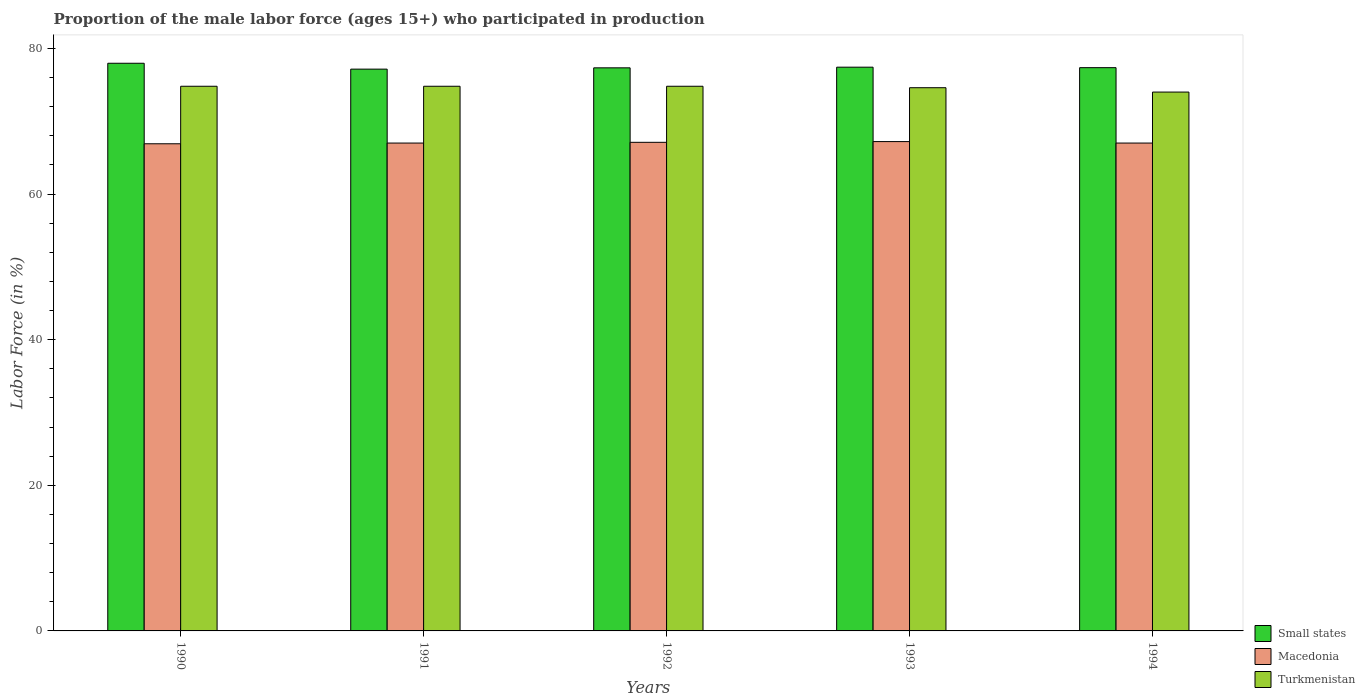How many groups of bars are there?
Give a very brief answer. 5. Are the number of bars on each tick of the X-axis equal?
Ensure brevity in your answer.  Yes. How many bars are there on the 1st tick from the left?
Your answer should be compact. 3. How many bars are there on the 2nd tick from the right?
Your response must be concise. 3. What is the label of the 4th group of bars from the left?
Provide a short and direct response. 1993. What is the proportion of the male labor force who participated in production in Turkmenistan in 1991?
Your answer should be very brief. 74.8. Across all years, what is the maximum proportion of the male labor force who participated in production in Small states?
Offer a terse response. 77.96. Across all years, what is the minimum proportion of the male labor force who participated in production in Macedonia?
Your answer should be very brief. 66.9. In which year was the proportion of the male labor force who participated in production in Small states maximum?
Give a very brief answer. 1990. In which year was the proportion of the male labor force who participated in production in Turkmenistan minimum?
Your response must be concise. 1994. What is the total proportion of the male labor force who participated in production in Turkmenistan in the graph?
Provide a short and direct response. 373. What is the difference between the proportion of the male labor force who participated in production in Turkmenistan in 1991 and that in 1993?
Ensure brevity in your answer.  0.2. What is the difference between the proportion of the male labor force who participated in production in Macedonia in 1992 and the proportion of the male labor force who participated in production in Turkmenistan in 1990?
Keep it short and to the point. -7.7. What is the average proportion of the male labor force who participated in production in Macedonia per year?
Provide a short and direct response. 67.04. In the year 1990, what is the difference between the proportion of the male labor force who participated in production in Macedonia and proportion of the male labor force who participated in production in Small states?
Keep it short and to the point. -11.06. What is the ratio of the proportion of the male labor force who participated in production in Macedonia in 1990 to that in 1991?
Give a very brief answer. 1. Is the proportion of the male labor force who participated in production in Macedonia in 1992 less than that in 1993?
Offer a very short reply. Yes. What is the difference between the highest and the second highest proportion of the male labor force who participated in production in Small states?
Make the answer very short. 0.54. What is the difference between the highest and the lowest proportion of the male labor force who participated in production in Small states?
Keep it short and to the point. 0.81. Is the sum of the proportion of the male labor force who participated in production in Small states in 1992 and 1994 greater than the maximum proportion of the male labor force who participated in production in Turkmenistan across all years?
Make the answer very short. Yes. What does the 3rd bar from the left in 1992 represents?
Ensure brevity in your answer.  Turkmenistan. What does the 3rd bar from the right in 1993 represents?
Provide a succinct answer. Small states. Is it the case that in every year, the sum of the proportion of the male labor force who participated in production in Small states and proportion of the male labor force who participated in production in Turkmenistan is greater than the proportion of the male labor force who participated in production in Macedonia?
Ensure brevity in your answer.  Yes. How many bars are there?
Keep it short and to the point. 15. Are all the bars in the graph horizontal?
Offer a terse response. No. Are the values on the major ticks of Y-axis written in scientific E-notation?
Your response must be concise. No. Does the graph contain grids?
Provide a succinct answer. No. Where does the legend appear in the graph?
Your response must be concise. Bottom right. How many legend labels are there?
Provide a succinct answer. 3. How are the legend labels stacked?
Your answer should be compact. Vertical. What is the title of the graph?
Provide a short and direct response. Proportion of the male labor force (ages 15+) who participated in production. Does "Timor-Leste" appear as one of the legend labels in the graph?
Provide a short and direct response. No. What is the Labor Force (in %) in Small states in 1990?
Your answer should be very brief. 77.96. What is the Labor Force (in %) of Macedonia in 1990?
Offer a terse response. 66.9. What is the Labor Force (in %) in Turkmenistan in 1990?
Give a very brief answer. 74.8. What is the Labor Force (in %) of Small states in 1991?
Your answer should be compact. 77.15. What is the Labor Force (in %) in Macedonia in 1991?
Give a very brief answer. 67. What is the Labor Force (in %) in Turkmenistan in 1991?
Provide a succinct answer. 74.8. What is the Labor Force (in %) in Small states in 1992?
Your answer should be very brief. 77.33. What is the Labor Force (in %) of Macedonia in 1992?
Offer a terse response. 67.1. What is the Labor Force (in %) in Turkmenistan in 1992?
Your answer should be compact. 74.8. What is the Labor Force (in %) of Small states in 1993?
Keep it short and to the point. 77.42. What is the Labor Force (in %) in Macedonia in 1993?
Your answer should be compact. 67.2. What is the Labor Force (in %) of Turkmenistan in 1993?
Your response must be concise. 74.6. What is the Labor Force (in %) of Small states in 1994?
Your answer should be compact. 77.35. What is the Labor Force (in %) of Macedonia in 1994?
Provide a succinct answer. 67. What is the Labor Force (in %) in Turkmenistan in 1994?
Your response must be concise. 74. Across all years, what is the maximum Labor Force (in %) in Small states?
Give a very brief answer. 77.96. Across all years, what is the maximum Labor Force (in %) of Macedonia?
Make the answer very short. 67.2. Across all years, what is the maximum Labor Force (in %) in Turkmenistan?
Your response must be concise. 74.8. Across all years, what is the minimum Labor Force (in %) in Small states?
Your response must be concise. 77.15. Across all years, what is the minimum Labor Force (in %) in Macedonia?
Provide a succinct answer. 66.9. What is the total Labor Force (in %) in Small states in the graph?
Your answer should be compact. 387.21. What is the total Labor Force (in %) in Macedonia in the graph?
Give a very brief answer. 335.2. What is the total Labor Force (in %) in Turkmenistan in the graph?
Provide a short and direct response. 373. What is the difference between the Labor Force (in %) of Small states in 1990 and that in 1991?
Provide a succinct answer. 0.81. What is the difference between the Labor Force (in %) of Small states in 1990 and that in 1992?
Offer a terse response. 0.63. What is the difference between the Labor Force (in %) in Macedonia in 1990 and that in 1992?
Keep it short and to the point. -0.2. What is the difference between the Labor Force (in %) in Small states in 1990 and that in 1993?
Keep it short and to the point. 0.54. What is the difference between the Labor Force (in %) in Macedonia in 1990 and that in 1993?
Your answer should be very brief. -0.3. What is the difference between the Labor Force (in %) in Turkmenistan in 1990 and that in 1993?
Provide a succinct answer. 0.2. What is the difference between the Labor Force (in %) of Small states in 1990 and that in 1994?
Your answer should be very brief. 0.61. What is the difference between the Labor Force (in %) in Turkmenistan in 1990 and that in 1994?
Keep it short and to the point. 0.8. What is the difference between the Labor Force (in %) of Small states in 1991 and that in 1992?
Your answer should be compact. -0.18. What is the difference between the Labor Force (in %) of Macedonia in 1991 and that in 1992?
Give a very brief answer. -0.1. What is the difference between the Labor Force (in %) in Small states in 1991 and that in 1993?
Keep it short and to the point. -0.27. What is the difference between the Labor Force (in %) in Macedonia in 1991 and that in 1993?
Keep it short and to the point. -0.2. What is the difference between the Labor Force (in %) in Turkmenistan in 1991 and that in 1993?
Give a very brief answer. 0.2. What is the difference between the Labor Force (in %) in Small states in 1991 and that in 1994?
Provide a short and direct response. -0.2. What is the difference between the Labor Force (in %) in Small states in 1992 and that in 1993?
Make the answer very short. -0.09. What is the difference between the Labor Force (in %) in Macedonia in 1992 and that in 1993?
Your answer should be very brief. -0.1. What is the difference between the Labor Force (in %) in Small states in 1992 and that in 1994?
Keep it short and to the point. -0.02. What is the difference between the Labor Force (in %) of Macedonia in 1992 and that in 1994?
Offer a very short reply. 0.1. What is the difference between the Labor Force (in %) in Turkmenistan in 1992 and that in 1994?
Offer a terse response. 0.8. What is the difference between the Labor Force (in %) of Small states in 1993 and that in 1994?
Provide a short and direct response. 0.07. What is the difference between the Labor Force (in %) of Turkmenistan in 1993 and that in 1994?
Ensure brevity in your answer.  0.6. What is the difference between the Labor Force (in %) in Small states in 1990 and the Labor Force (in %) in Macedonia in 1991?
Make the answer very short. 10.96. What is the difference between the Labor Force (in %) of Small states in 1990 and the Labor Force (in %) of Turkmenistan in 1991?
Your response must be concise. 3.16. What is the difference between the Labor Force (in %) in Small states in 1990 and the Labor Force (in %) in Macedonia in 1992?
Give a very brief answer. 10.86. What is the difference between the Labor Force (in %) in Small states in 1990 and the Labor Force (in %) in Turkmenistan in 1992?
Provide a short and direct response. 3.16. What is the difference between the Labor Force (in %) of Macedonia in 1990 and the Labor Force (in %) of Turkmenistan in 1992?
Make the answer very short. -7.9. What is the difference between the Labor Force (in %) of Small states in 1990 and the Labor Force (in %) of Macedonia in 1993?
Keep it short and to the point. 10.76. What is the difference between the Labor Force (in %) in Small states in 1990 and the Labor Force (in %) in Turkmenistan in 1993?
Offer a terse response. 3.36. What is the difference between the Labor Force (in %) of Macedonia in 1990 and the Labor Force (in %) of Turkmenistan in 1993?
Make the answer very short. -7.7. What is the difference between the Labor Force (in %) of Small states in 1990 and the Labor Force (in %) of Macedonia in 1994?
Ensure brevity in your answer.  10.96. What is the difference between the Labor Force (in %) of Small states in 1990 and the Labor Force (in %) of Turkmenistan in 1994?
Keep it short and to the point. 3.96. What is the difference between the Labor Force (in %) in Macedonia in 1990 and the Labor Force (in %) in Turkmenistan in 1994?
Your answer should be very brief. -7.1. What is the difference between the Labor Force (in %) in Small states in 1991 and the Labor Force (in %) in Macedonia in 1992?
Offer a terse response. 10.05. What is the difference between the Labor Force (in %) of Small states in 1991 and the Labor Force (in %) of Turkmenistan in 1992?
Your answer should be compact. 2.35. What is the difference between the Labor Force (in %) in Small states in 1991 and the Labor Force (in %) in Macedonia in 1993?
Ensure brevity in your answer.  9.95. What is the difference between the Labor Force (in %) of Small states in 1991 and the Labor Force (in %) of Turkmenistan in 1993?
Ensure brevity in your answer.  2.55. What is the difference between the Labor Force (in %) of Small states in 1991 and the Labor Force (in %) of Macedonia in 1994?
Offer a very short reply. 10.15. What is the difference between the Labor Force (in %) in Small states in 1991 and the Labor Force (in %) in Turkmenistan in 1994?
Offer a very short reply. 3.15. What is the difference between the Labor Force (in %) in Small states in 1992 and the Labor Force (in %) in Macedonia in 1993?
Ensure brevity in your answer.  10.13. What is the difference between the Labor Force (in %) in Small states in 1992 and the Labor Force (in %) in Turkmenistan in 1993?
Give a very brief answer. 2.73. What is the difference between the Labor Force (in %) in Macedonia in 1992 and the Labor Force (in %) in Turkmenistan in 1993?
Provide a short and direct response. -7.5. What is the difference between the Labor Force (in %) of Small states in 1992 and the Labor Force (in %) of Macedonia in 1994?
Ensure brevity in your answer.  10.33. What is the difference between the Labor Force (in %) in Small states in 1992 and the Labor Force (in %) in Turkmenistan in 1994?
Offer a terse response. 3.33. What is the difference between the Labor Force (in %) in Small states in 1993 and the Labor Force (in %) in Macedonia in 1994?
Offer a terse response. 10.42. What is the difference between the Labor Force (in %) in Small states in 1993 and the Labor Force (in %) in Turkmenistan in 1994?
Keep it short and to the point. 3.42. What is the difference between the Labor Force (in %) in Macedonia in 1993 and the Labor Force (in %) in Turkmenistan in 1994?
Offer a very short reply. -6.8. What is the average Labor Force (in %) in Small states per year?
Make the answer very short. 77.44. What is the average Labor Force (in %) in Macedonia per year?
Ensure brevity in your answer.  67.04. What is the average Labor Force (in %) of Turkmenistan per year?
Offer a very short reply. 74.6. In the year 1990, what is the difference between the Labor Force (in %) of Small states and Labor Force (in %) of Macedonia?
Your response must be concise. 11.06. In the year 1990, what is the difference between the Labor Force (in %) of Small states and Labor Force (in %) of Turkmenistan?
Ensure brevity in your answer.  3.16. In the year 1990, what is the difference between the Labor Force (in %) in Macedonia and Labor Force (in %) in Turkmenistan?
Keep it short and to the point. -7.9. In the year 1991, what is the difference between the Labor Force (in %) in Small states and Labor Force (in %) in Macedonia?
Keep it short and to the point. 10.15. In the year 1991, what is the difference between the Labor Force (in %) in Small states and Labor Force (in %) in Turkmenistan?
Ensure brevity in your answer.  2.35. In the year 1992, what is the difference between the Labor Force (in %) in Small states and Labor Force (in %) in Macedonia?
Your response must be concise. 10.23. In the year 1992, what is the difference between the Labor Force (in %) of Small states and Labor Force (in %) of Turkmenistan?
Offer a very short reply. 2.53. In the year 1993, what is the difference between the Labor Force (in %) in Small states and Labor Force (in %) in Macedonia?
Offer a terse response. 10.22. In the year 1993, what is the difference between the Labor Force (in %) in Small states and Labor Force (in %) in Turkmenistan?
Your response must be concise. 2.82. In the year 1993, what is the difference between the Labor Force (in %) of Macedonia and Labor Force (in %) of Turkmenistan?
Give a very brief answer. -7.4. In the year 1994, what is the difference between the Labor Force (in %) of Small states and Labor Force (in %) of Macedonia?
Provide a succinct answer. 10.35. In the year 1994, what is the difference between the Labor Force (in %) of Small states and Labor Force (in %) of Turkmenistan?
Provide a short and direct response. 3.35. In the year 1994, what is the difference between the Labor Force (in %) in Macedonia and Labor Force (in %) in Turkmenistan?
Offer a terse response. -7. What is the ratio of the Labor Force (in %) in Small states in 1990 to that in 1991?
Make the answer very short. 1.01. What is the ratio of the Labor Force (in %) of Turkmenistan in 1990 to that in 1991?
Provide a short and direct response. 1. What is the ratio of the Labor Force (in %) in Small states in 1990 to that in 1992?
Keep it short and to the point. 1.01. What is the ratio of the Labor Force (in %) in Macedonia in 1990 to that in 1992?
Make the answer very short. 1. What is the ratio of the Labor Force (in %) of Macedonia in 1990 to that in 1994?
Keep it short and to the point. 1. What is the ratio of the Labor Force (in %) of Turkmenistan in 1990 to that in 1994?
Keep it short and to the point. 1.01. What is the ratio of the Labor Force (in %) in Small states in 1991 to that in 1992?
Your answer should be very brief. 1. What is the ratio of the Labor Force (in %) in Macedonia in 1991 to that in 1993?
Provide a short and direct response. 1. What is the ratio of the Labor Force (in %) of Small states in 1991 to that in 1994?
Your response must be concise. 1. What is the ratio of the Labor Force (in %) in Turkmenistan in 1991 to that in 1994?
Keep it short and to the point. 1.01. What is the ratio of the Labor Force (in %) in Small states in 1992 to that in 1993?
Provide a short and direct response. 1. What is the ratio of the Labor Force (in %) of Macedonia in 1992 to that in 1993?
Your response must be concise. 1. What is the ratio of the Labor Force (in %) in Turkmenistan in 1992 to that in 1993?
Keep it short and to the point. 1. What is the ratio of the Labor Force (in %) in Macedonia in 1992 to that in 1994?
Your answer should be very brief. 1. What is the ratio of the Labor Force (in %) of Turkmenistan in 1992 to that in 1994?
Keep it short and to the point. 1.01. What is the ratio of the Labor Force (in %) in Small states in 1993 to that in 1994?
Give a very brief answer. 1. What is the ratio of the Labor Force (in %) of Turkmenistan in 1993 to that in 1994?
Give a very brief answer. 1.01. What is the difference between the highest and the second highest Labor Force (in %) of Small states?
Offer a very short reply. 0.54. What is the difference between the highest and the second highest Labor Force (in %) in Macedonia?
Make the answer very short. 0.1. What is the difference between the highest and the second highest Labor Force (in %) in Turkmenistan?
Your answer should be very brief. 0. What is the difference between the highest and the lowest Labor Force (in %) in Small states?
Provide a short and direct response. 0.81. 